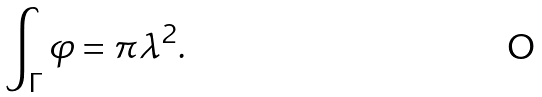Convert formula to latex. <formula><loc_0><loc_0><loc_500><loc_500>\int _ { \Gamma } \varphi = \pi \lambda ^ { 2 } .</formula> 